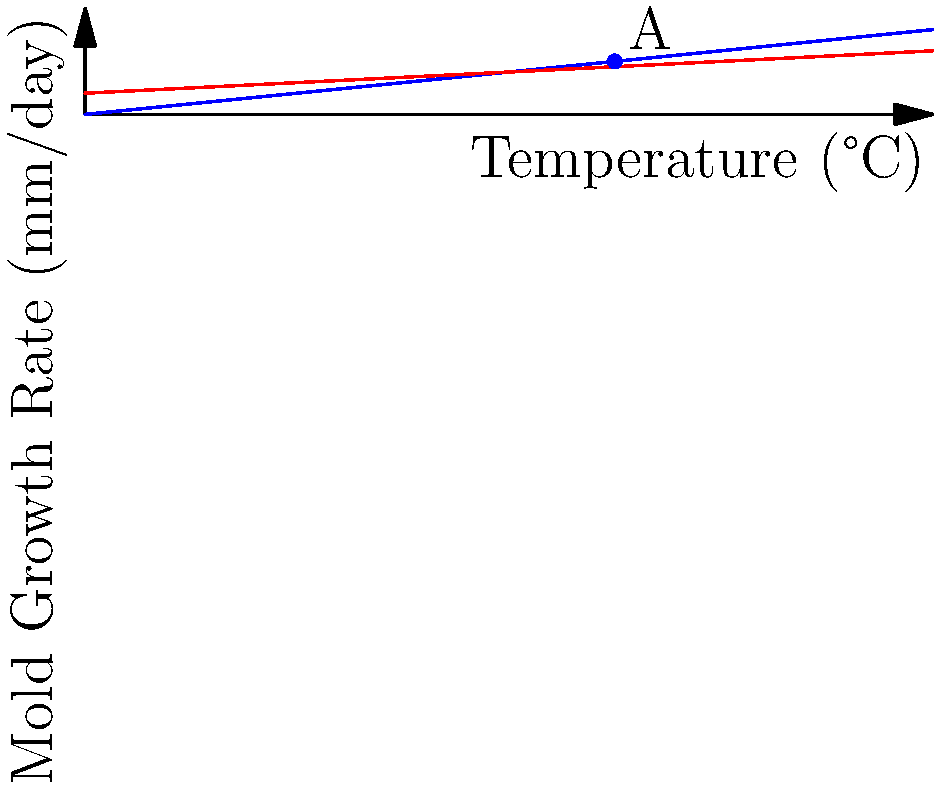The graph shows mold growth rates in dry and humid environments at various temperatures. At what temperature do both environments have the same mold growth rate, and what is that rate? To solve this problem, we need to follow these steps:

1. Identify the equations for each line:
   - Dry Environment (blue): $y = 0.1x$
   - Humid Environment (red): $y = 0.05x + 1$

2. To find where the growth rates are the same, we set the equations equal to each other:
   $0.1x = 0.05x + 1$

3. Solve for $x$:
   $0.1x - 0.05x = 1$
   $0.05x = 1$
   $x = 20$

4. Calculate the growth rate at this temperature by plugging $x = 20$ into either equation:
   $y = 0.1(20) = 2$ mm/day

5. Verify visually that the point (20, 2) is where the lines intersect on the graph.

Therefore, both environments have the same mold growth rate at 20°C, and that rate is 2 mm/day.
Answer: 20°C, 2 mm/day 